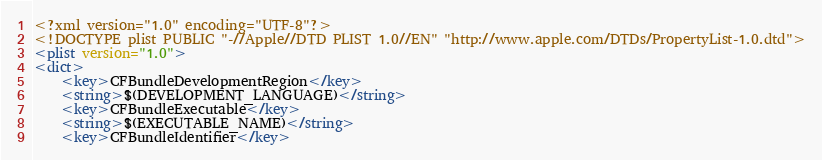<code> <loc_0><loc_0><loc_500><loc_500><_XML_><?xml version="1.0" encoding="UTF-8"?>
<!DOCTYPE plist PUBLIC "-//Apple//DTD PLIST 1.0//EN" "http://www.apple.com/DTDs/PropertyList-1.0.dtd">
<plist version="1.0">
<dict>
	<key>CFBundleDevelopmentRegion</key>
	<string>$(DEVELOPMENT_LANGUAGE)</string>
	<key>CFBundleExecutable</key>
	<string>$(EXECUTABLE_NAME)</string>
	<key>CFBundleIdentifier</key></code> 